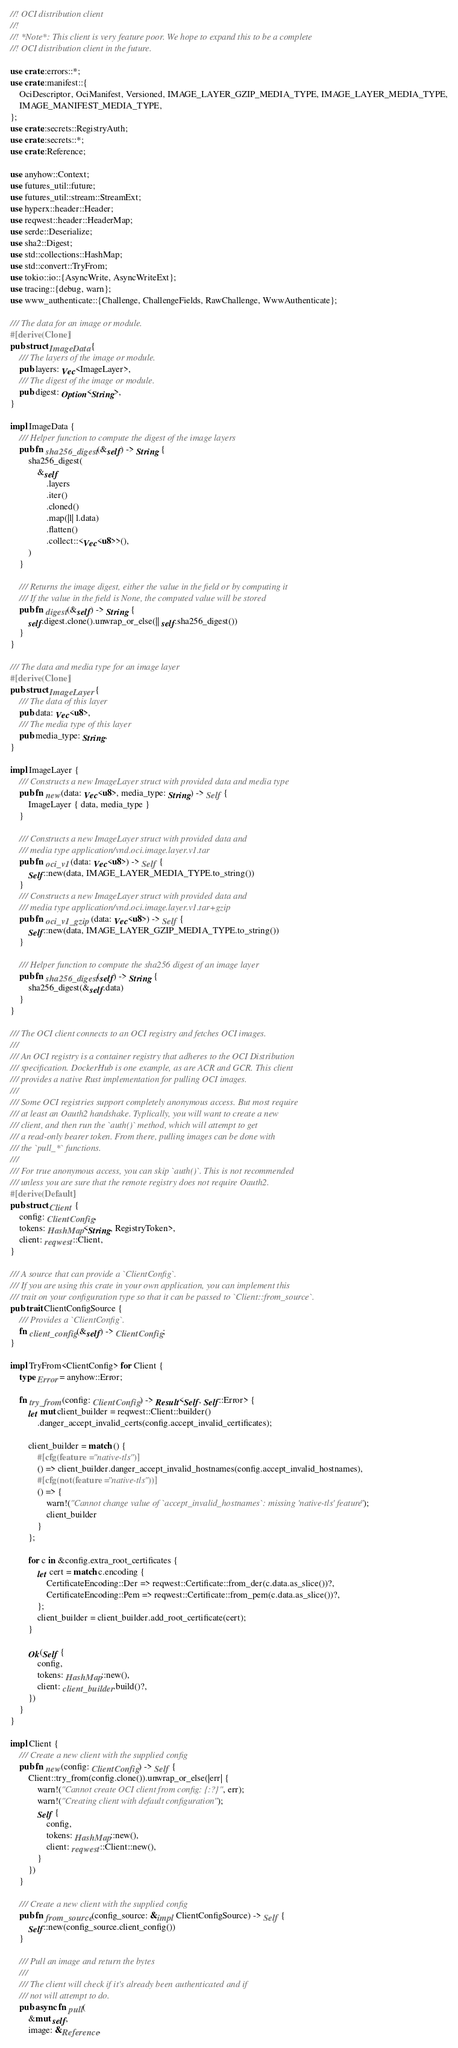<code> <loc_0><loc_0><loc_500><loc_500><_Rust_>//! OCI distribution client
//!
//! *Note*: This client is very feature poor. We hope to expand this to be a complete
//! OCI distribution client in the future.

use crate::errors::*;
use crate::manifest::{
    OciDescriptor, OciManifest, Versioned, IMAGE_LAYER_GZIP_MEDIA_TYPE, IMAGE_LAYER_MEDIA_TYPE,
    IMAGE_MANIFEST_MEDIA_TYPE,
};
use crate::secrets::RegistryAuth;
use crate::secrets::*;
use crate::Reference;

use anyhow::Context;
use futures_util::future;
use futures_util::stream::StreamExt;
use hyperx::header::Header;
use reqwest::header::HeaderMap;
use serde::Deserialize;
use sha2::Digest;
use std::collections::HashMap;
use std::convert::TryFrom;
use tokio::io::{AsyncWrite, AsyncWriteExt};
use tracing::{debug, warn};
use www_authenticate::{Challenge, ChallengeFields, RawChallenge, WwwAuthenticate};

/// The data for an image or module.
#[derive(Clone)]
pub struct ImageData {
    /// The layers of the image or module.
    pub layers: Vec<ImageLayer>,
    /// The digest of the image or module.
    pub digest: Option<String>,
}

impl ImageData {
    /// Helper function to compute the digest of the image layers
    pub fn sha256_digest(&self) -> String {
        sha256_digest(
            &self
                .layers
                .iter()
                .cloned()
                .map(|l| l.data)
                .flatten()
                .collect::<Vec<u8>>(),
        )
    }

    /// Returns the image digest, either the value in the field or by computing it
    /// If the value in the field is None, the computed value will be stored
    pub fn digest(&self) -> String {
        self.digest.clone().unwrap_or_else(|| self.sha256_digest())
    }
}

/// The data and media type for an image layer
#[derive(Clone)]
pub struct ImageLayer {
    /// The data of this layer
    pub data: Vec<u8>,
    /// The media type of this layer
    pub media_type: String,
}

impl ImageLayer {
    /// Constructs a new ImageLayer struct with provided data and media type
    pub fn new(data: Vec<u8>, media_type: String) -> Self {
        ImageLayer { data, media_type }
    }

    /// Constructs a new ImageLayer struct with provided data and
    /// media type application/vnd.oci.image.layer.v1.tar
    pub fn oci_v1(data: Vec<u8>) -> Self {
        Self::new(data, IMAGE_LAYER_MEDIA_TYPE.to_string())
    }
    /// Constructs a new ImageLayer struct with provided data and
    /// media type application/vnd.oci.image.layer.v1.tar+gzip
    pub fn oci_v1_gzip(data: Vec<u8>) -> Self {
        Self::new(data, IMAGE_LAYER_GZIP_MEDIA_TYPE.to_string())
    }

    /// Helper function to compute the sha256 digest of an image layer
    pub fn sha256_digest(self) -> String {
        sha256_digest(&self.data)
    }
}

/// The OCI client connects to an OCI registry and fetches OCI images.
///
/// An OCI registry is a container registry that adheres to the OCI Distribution
/// specification. DockerHub is one example, as are ACR and GCR. This client
/// provides a native Rust implementation for pulling OCI images.
///
/// Some OCI registries support completely anonymous access. But most require
/// at least an Oauth2 handshake. Typlically, you will want to create a new
/// client, and then run the `auth()` method, which will attempt to get
/// a read-only bearer token. From there, pulling images can be done with
/// the `pull_*` functions.
///
/// For true anonymous access, you can skip `auth()`. This is not recommended
/// unless you are sure that the remote registry does not require Oauth2.
#[derive(Default)]
pub struct Client {
    config: ClientConfig,
    tokens: HashMap<String, RegistryToken>,
    client: reqwest::Client,
}

/// A source that can provide a `ClientConfig`.
/// If you are using this crate in your own application, you can implement this
/// trait on your configuration type so that it can be passed to `Client::from_source`.
pub trait ClientConfigSource {
    /// Provides a `ClientConfig`.
    fn client_config(&self) -> ClientConfig;
}

impl TryFrom<ClientConfig> for Client {
    type Error = anyhow::Error;

    fn try_from(config: ClientConfig) -> Result<Self, Self::Error> {
        let mut client_builder = reqwest::Client::builder()
            .danger_accept_invalid_certs(config.accept_invalid_certificates);

        client_builder = match () {
            #[cfg(feature = "native-tls")]
            () => client_builder.danger_accept_invalid_hostnames(config.accept_invalid_hostnames),
            #[cfg(not(feature = "native-tls"))]
            () => {
                warn!("Cannot change value of `accept_invalid_hostnames`: missing 'native-tls' feature");
                client_builder
            }
        };

        for c in &config.extra_root_certificates {
            let cert = match c.encoding {
                CertificateEncoding::Der => reqwest::Certificate::from_der(c.data.as_slice())?,
                CertificateEncoding::Pem => reqwest::Certificate::from_pem(c.data.as_slice())?,
            };
            client_builder = client_builder.add_root_certificate(cert);
        }

        Ok(Self {
            config,
            tokens: HashMap::new(),
            client: client_builder.build()?,
        })
    }
}

impl Client {
    /// Create a new client with the supplied config
    pub fn new(config: ClientConfig) -> Self {
        Client::try_from(config.clone()).unwrap_or_else(|err| {
            warn!("Cannot create OCI client from config: {:?}", err);
            warn!("Creating client with default configuration");
            Self {
                config,
                tokens: HashMap::new(),
                client: reqwest::Client::new(),
            }
        })
    }

    /// Create a new client with the supplied config
    pub fn from_source(config_source: &impl ClientConfigSource) -> Self {
        Self::new(config_source.client_config())
    }

    /// Pull an image and return the bytes
    ///
    /// The client will check if it's already been authenticated and if
    /// not will attempt to do.
    pub async fn pull(
        &mut self,
        image: &Reference,</code> 